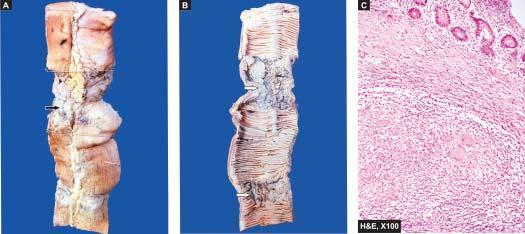does the external surface of small intestine show stricture and a lymph node in section having caseation necrosiss?
Answer the question using a single word or phrase. Yes 